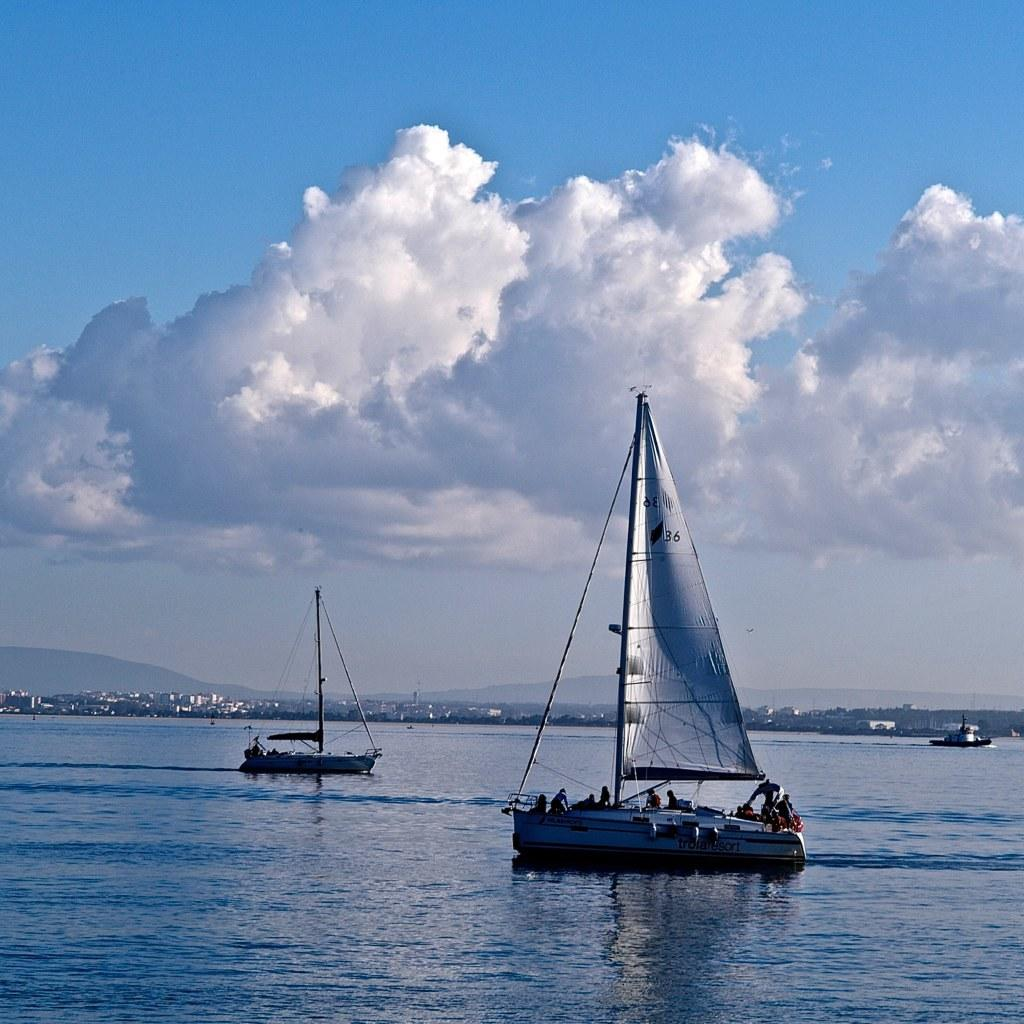What is on the water in the image? There are boats on the water in the image. What structures can be seen in the image? There are buildings visible in the image. What type of natural landform is present in the image? There are mountains in the image. What is visible in the background of the image? The sky is visible in the background of the image. What can be observed in the sky? Clouds are present in the sky. What type of jelly is being served on the sidewalk in the image? There is no jelly or sidewalk present in the image; it features boats on the water, buildings, mountains, and a sky with clouds. What meal is being prepared on the mountains in the image? There is no meal preparation or indication of a meal in the image; it only shows boats, buildings, mountains, and the sky. 